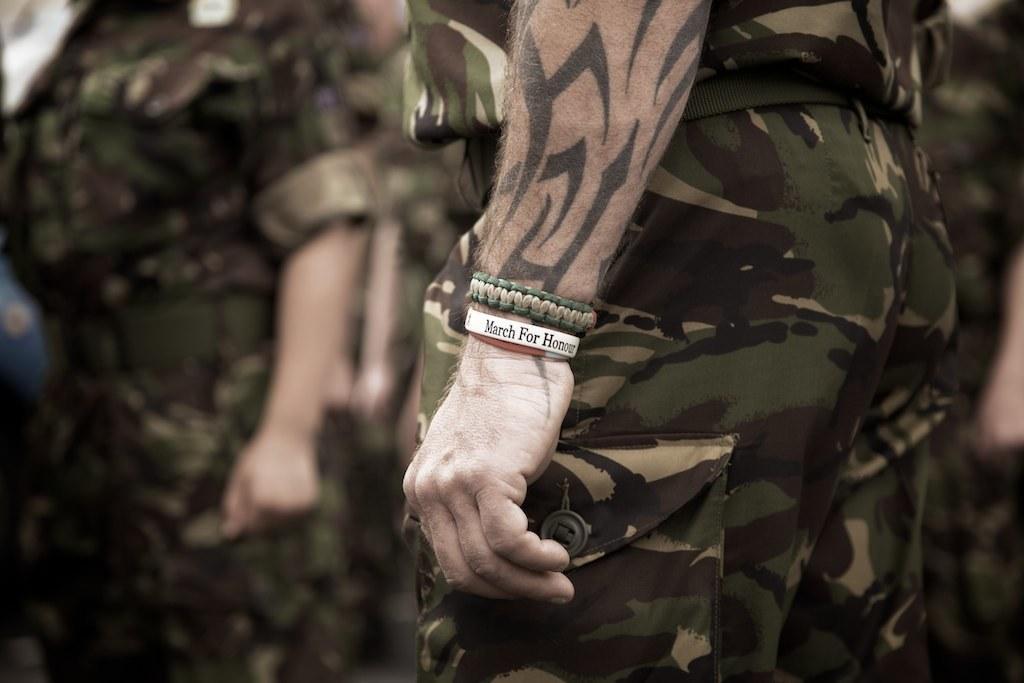Describe this image in one or two sentences. In this image we can see group of persons wearing military uniforms. One person is wearing bands on his hand. 